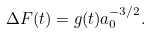Convert formula to latex. <formula><loc_0><loc_0><loc_500><loc_500>\Delta F ( t ) = g ( t ) a _ { 0 } ^ { - 3 / 2 } .</formula> 